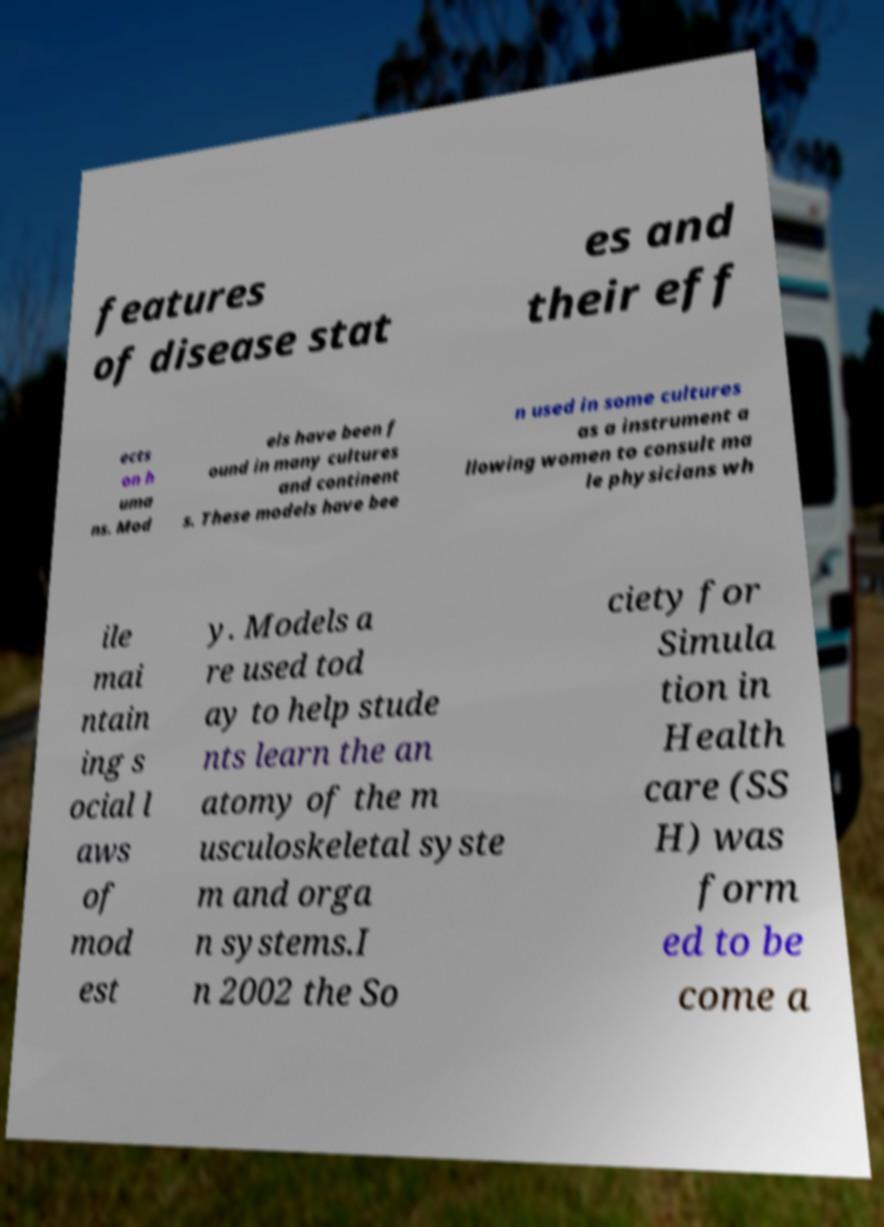Please read and relay the text visible in this image. What does it say? features of disease stat es and their eff ects on h uma ns. Mod els have been f ound in many cultures and continent s. These models have bee n used in some cultures as a instrument a llowing women to consult ma le physicians wh ile mai ntain ing s ocial l aws of mod est y. Models a re used tod ay to help stude nts learn the an atomy of the m usculoskeletal syste m and orga n systems.I n 2002 the So ciety for Simula tion in Health care (SS H) was form ed to be come a 